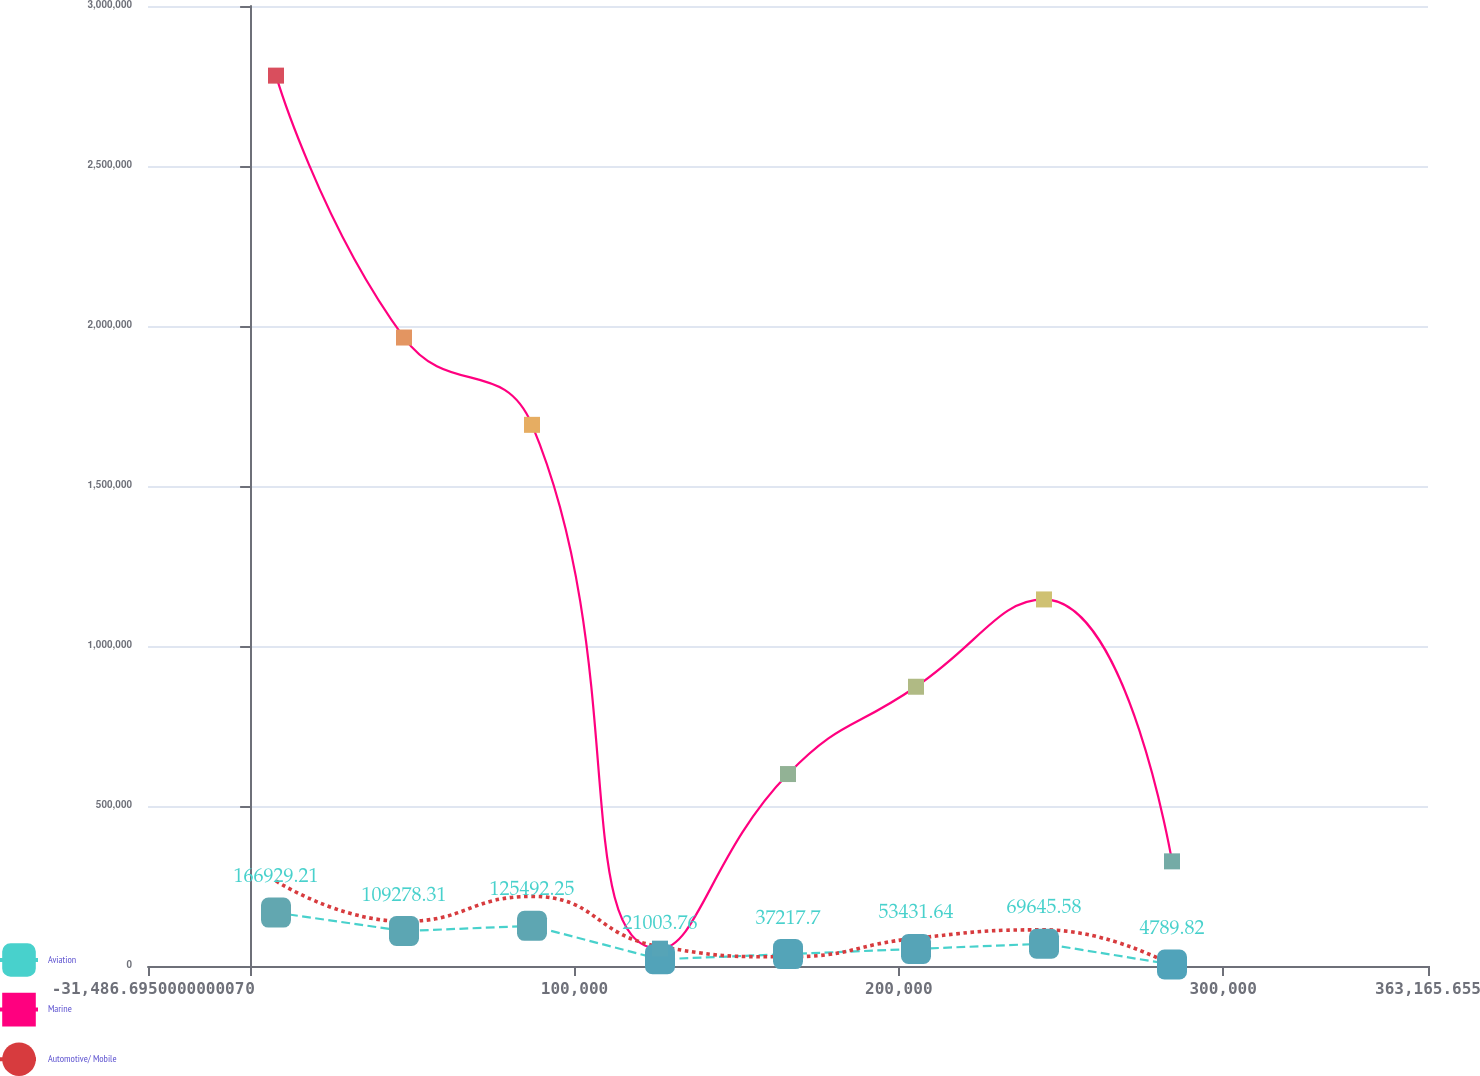Convert chart. <chart><loc_0><loc_0><loc_500><loc_500><line_chart><ecel><fcel>Aviation<fcel>Marine<fcel>Automotive/ Mobile<nl><fcel>7978.54<fcel>166929<fcel>2.78243e+06<fcel>265507<nl><fcel>47443.8<fcel>109278<fcel>1.96396e+06<fcel>139384<nl><fcel>86909<fcel>125492<fcel>1.69114e+06<fcel>217503<nl><fcel>126374<fcel>21003.8<fcel>54195.4<fcel>60464.4<nl><fcel>165839<fcel>37217.7<fcel>599843<fcel>28749.6<nl><fcel>205305<fcel>53431.6<fcel>872667<fcel>86770.8<nl><fcel>244770<fcel>69645.6<fcel>1.14549e+06<fcel>113077<nl><fcel>284235<fcel>4789.82<fcel>327019<fcel>2443.16<nl><fcel>402631<fcel>85859.5<fcel>1.41831e+06<fcel>165690<nl></chart> 